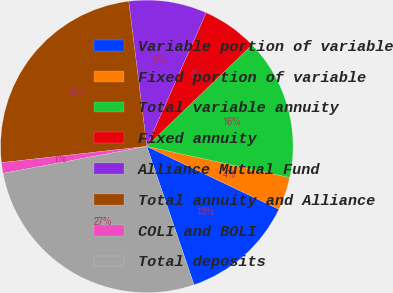Convert chart to OTSL. <chart><loc_0><loc_0><loc_500><loc_500><pie_chart><fcel>Variable portion of variable<fcel>Fixed portion of variable<fcel>Total variable annuity<fcel>Fixed annuity<fcel>Alliance Mutual Fund<fcel>Total annuity and Alliance<fcel>COLI and BOLI<fcel>Total deposits<nl><fcel>12.69%<fcel>3.66%<fcel>15.62%<fcel>6.14%<fcel>8.62%<fcel>24.8%<fcel>1.18%<fcel>27.28%<nl></chart> 